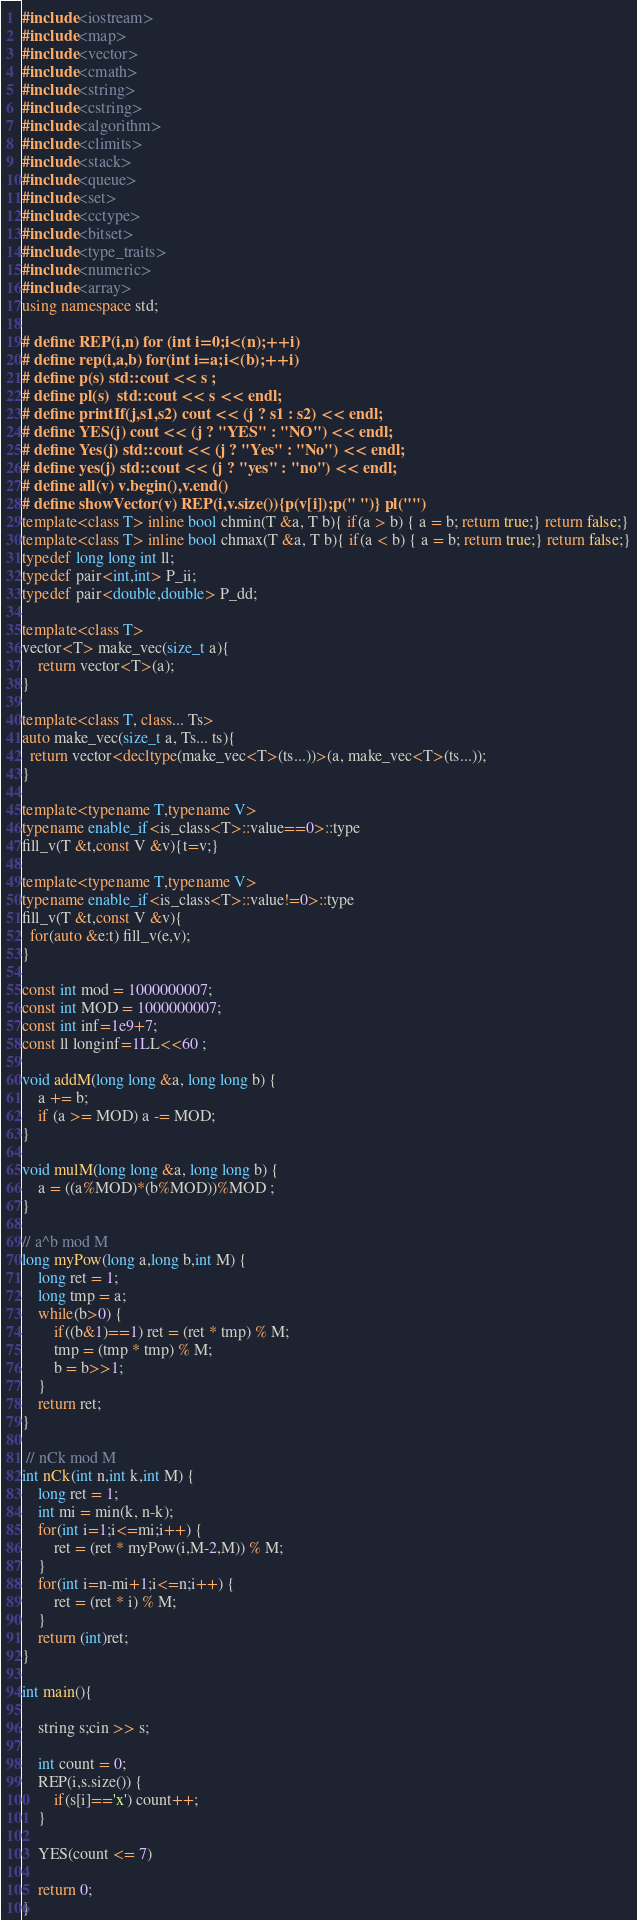Convert code to text. <code><loc_0><loc_0><loc_500><loc_500><_C++_>#include<iostream>
#include<map>
#include<vector>
#include<cmath>
#include<string>
#include<cstring>
#include<algorithm> 
#include<climits>
#include<stack>
#include<queue>
#include<set>
#include<cctype>
#include<bitset> 
#include<type_traits>
#include<numeric>
#include<array>
using namespace std;

# define REP(i,n) for (int i=0;i<(n);++i)
# define rep(i,a,b) for(int i=a;i<(b);++i)
# define p(s) std::cout << s ;
# define pl(s)  std::cout << s << endl;
# define printIf(j,s1,s2) cout << (j ? s1 : s2) << endl;
# define YES(j) cout << (j ? "YES" : "NO") << endl;
# define Yes(j) std::cout << (j ? "Yes" : "No") << endl;
# define yes(j) std::cout << (j ? "yes" : "no") << endl;
# define all(v) v.begin(),v.end()
# define showVector(v) REP(i,v.size()){p(v[i]);p(" ")} pl("")
template<class T> inline bool chmin(T &a, T b){ if(a > b) { a = b; return true;} return false;}
template<class T> inline bool chmax(T &a, T b){ if(a < b) { a = b; return true;} return false;}
typedef long long int ll;
typedef pair<int,int> P_ii;
typedef pair<double,double> P_dd;

template<class T>
vector<T> make_vec(size_t a){
    return vector<T>(a);
}

template<class T, class... Ts>
auto make_vec(size_t a, Ts... ts){
  return vector<decltype(make_vec<T>(ts...))>(a, make_vec<T>(ts...));
}

template<typename T,typename V>
typename enable_if<is_class<T>::value==0>::type
fill_v(T &t,const V &v){t=v;}

template<typename T,typename V>
typename enable_if<is_class<T>::value!=0>::type
fill_v(T &t,const V &v){
  for(auto &e:t) fill_v(e,v);
}

const int mod = 1000000007;
const int MOD = 1000000007;
const int inf=1e9+7;
const ll longinf=1LL<<60 ;

void addM(long long &a, long long b) {
    a += b;
    if (a >= MOD) a -= MOD;
}

void mulM(long long &a, long long b) {
    a = ((a%MOD)*(b%MOD))%MOD ;
}

// a^b mod M
long myPow(long a,long b,int M) {
    long ret = 1;
    long tmp = a;
    while(b>0) {
        if((b&1)==1) ret = (ret * tmp) % M;
        tmp = (tmp * tmp) % M;
        b = b>>1;
    }
    return ret;
}

 // nCk mod M
int nCk(int n,int k,int M) {
    long ret = 1;
    int mi = min(k, n-k);
    for(int i=1;i<=mi;i++) {
        ret = (ret * myPow(i,M-2,M)) % M;
    }
    for(int i=n-mi+1;i<=n;i++) {
        ret = (ret * i) % M;
    }
    return (int)ret;
}

int main(){

    string s;cin >> s;

    int count = 0;
    REP(i,s.size()) {
        if(s[i]=='x') count++;
    }

    YES(count <= 7)

    return 0;
}</code> 